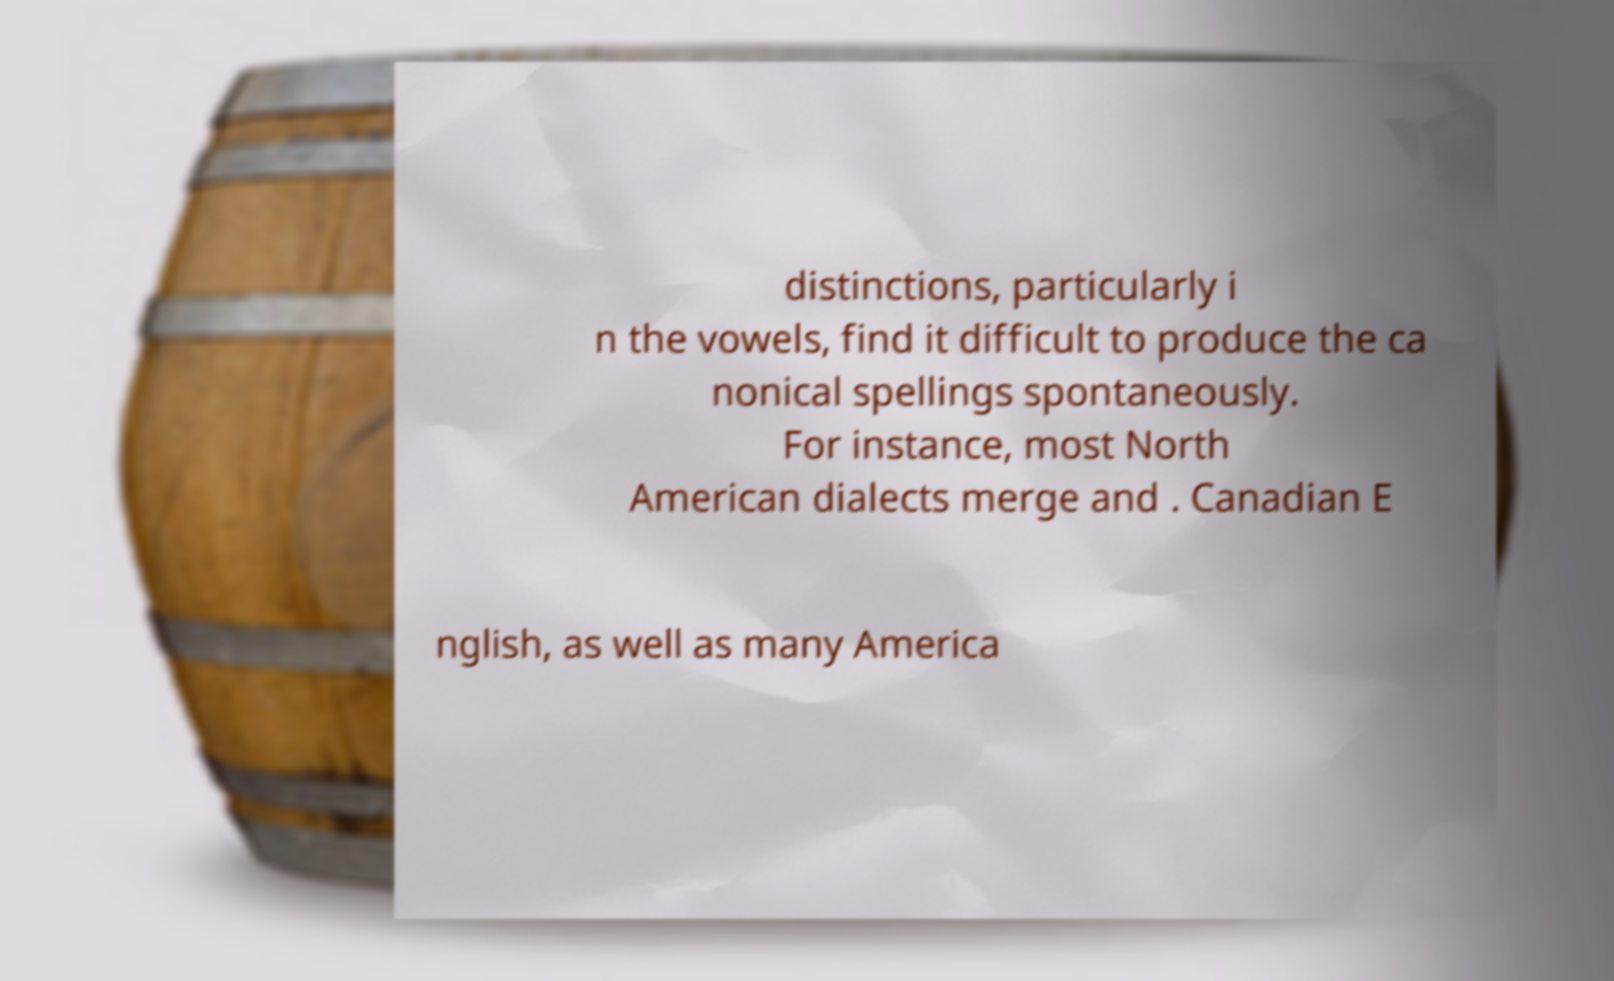What messages or text are displayed in this image? I need them in a readable, typed format. distinctions, particularly i n the vowels, find it difficult to produce the ca nonical spellings spontaneously. For instance, most North American dialects merge and . Canadian E nglish, as well as many America 